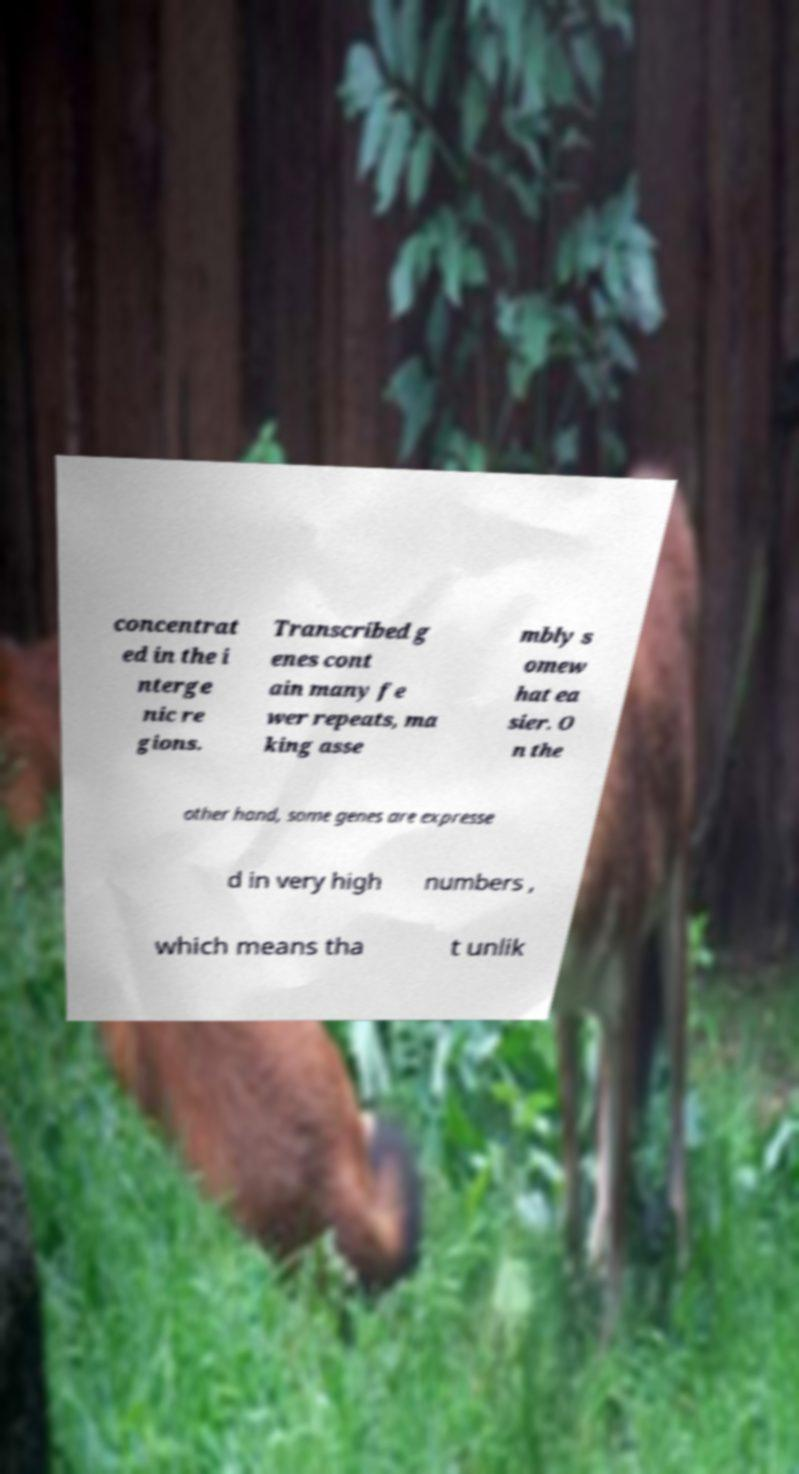Can you accurately transcribe the text from the provided image for me? concentrat ed in the i nterge nic re gions. Transcribed g enes cont ain many fe wer repeats, ma king asse mbly s omew hat ea sier. O n the other hand, some genes are expresse d in very high numbers , which means tha t unlik 